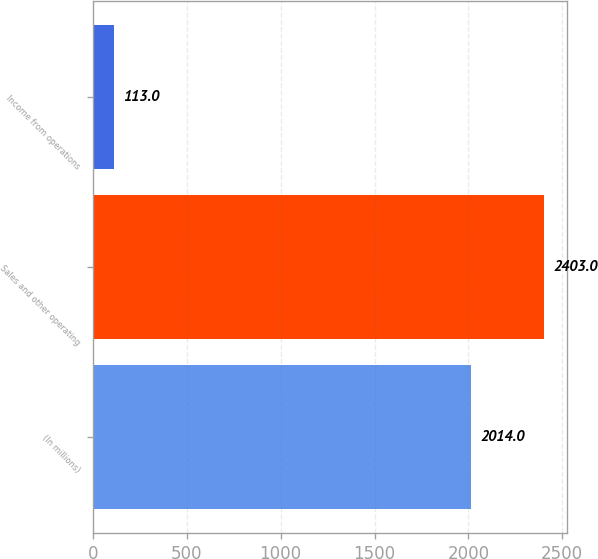Convert chart to OTSL. <chart><loc_0><loc_0><loc_500><loc_500><bar_chart><fcel>(In millions)<fcel>Sales and other operating<fcel>Income from operations<nl><fcel>2014<fcel>2403<fcel>113<nl></chart> 